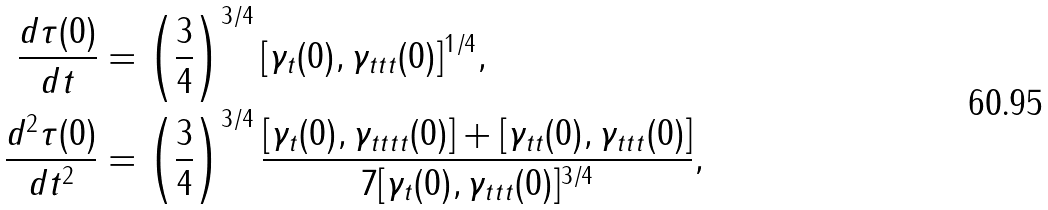<formula> <loc_0><loc_0><loc_500><loc_500>\frac { d \tau ( 0 ) } { d t } & = \left ( \frac { 3 } 4 \right ) ^ { 3 / 4 } [ \gamma _ { t } ( 0 ) , \gamma _ { t t t } ( 0 ) ] ^ { 1 / 4 } , \\ \frac { d ^ { 2 } \tau ( 0 ) } { d t ^ { 2 } } & = \left ( \frac { 3 } 4 \right ) ^ { 3 / 4 } \frac { [ \gamma _ { t } ( 0 ) , \gamma _ { t t t t } ( 0 ) ] + [ \gamma _ { t t } ( 0 ) , \gamma _ { t t t } ( 0 ) ] } { 7 [ \gamma _ { t } ( 0 ) , \gamma _ { t t t } ( 0 ) ] ^ { 3 / 4 } } ,</formula> 